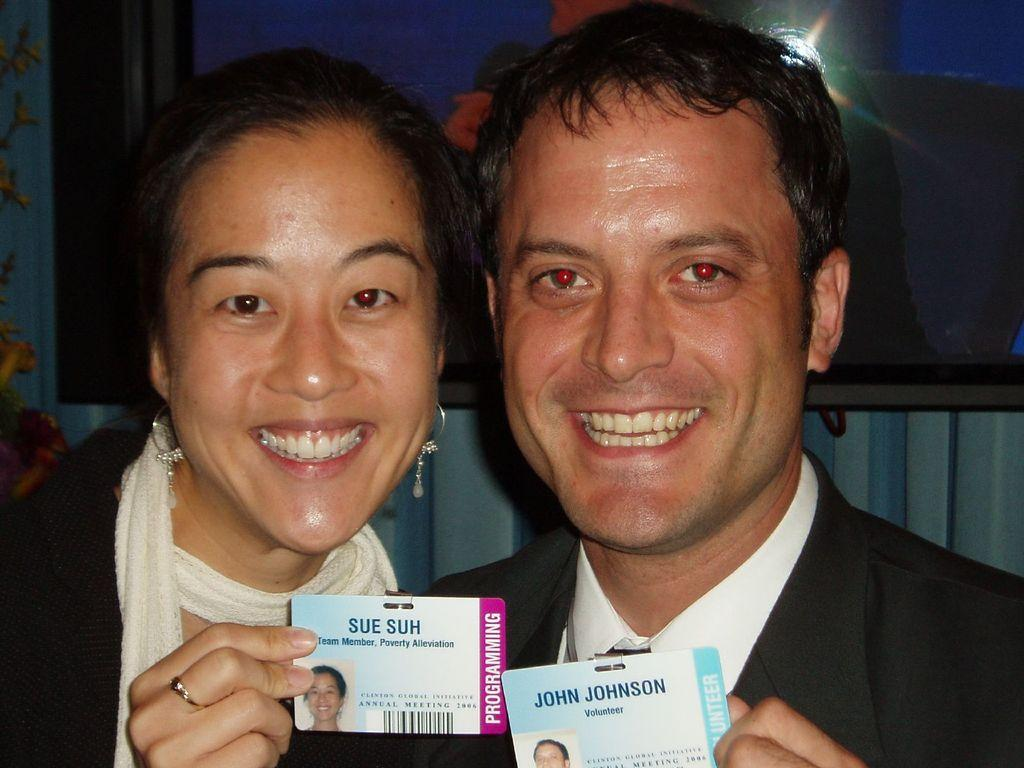How many people are in the image? There are two people in the image, a man and a woman. What are the man and the woman doing in the image? Both the man and the woman are laughing and catching identity cards with their hands. What can be seen in the background of the image? There is a wall in the background of the image. Is there any additional decoration or object on the wall? There may be a frame on the wall. What type of crayon can be seen in the image? There is no crayon present in the image. What is the engine's horsepower in the image? There is no engine present in the image, so it is not possible to determine its horsepower. 